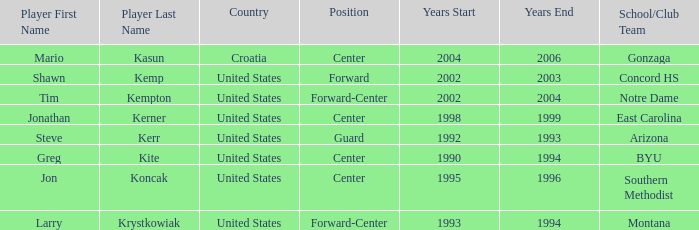What nationality has steve kerr as the player? United States. 